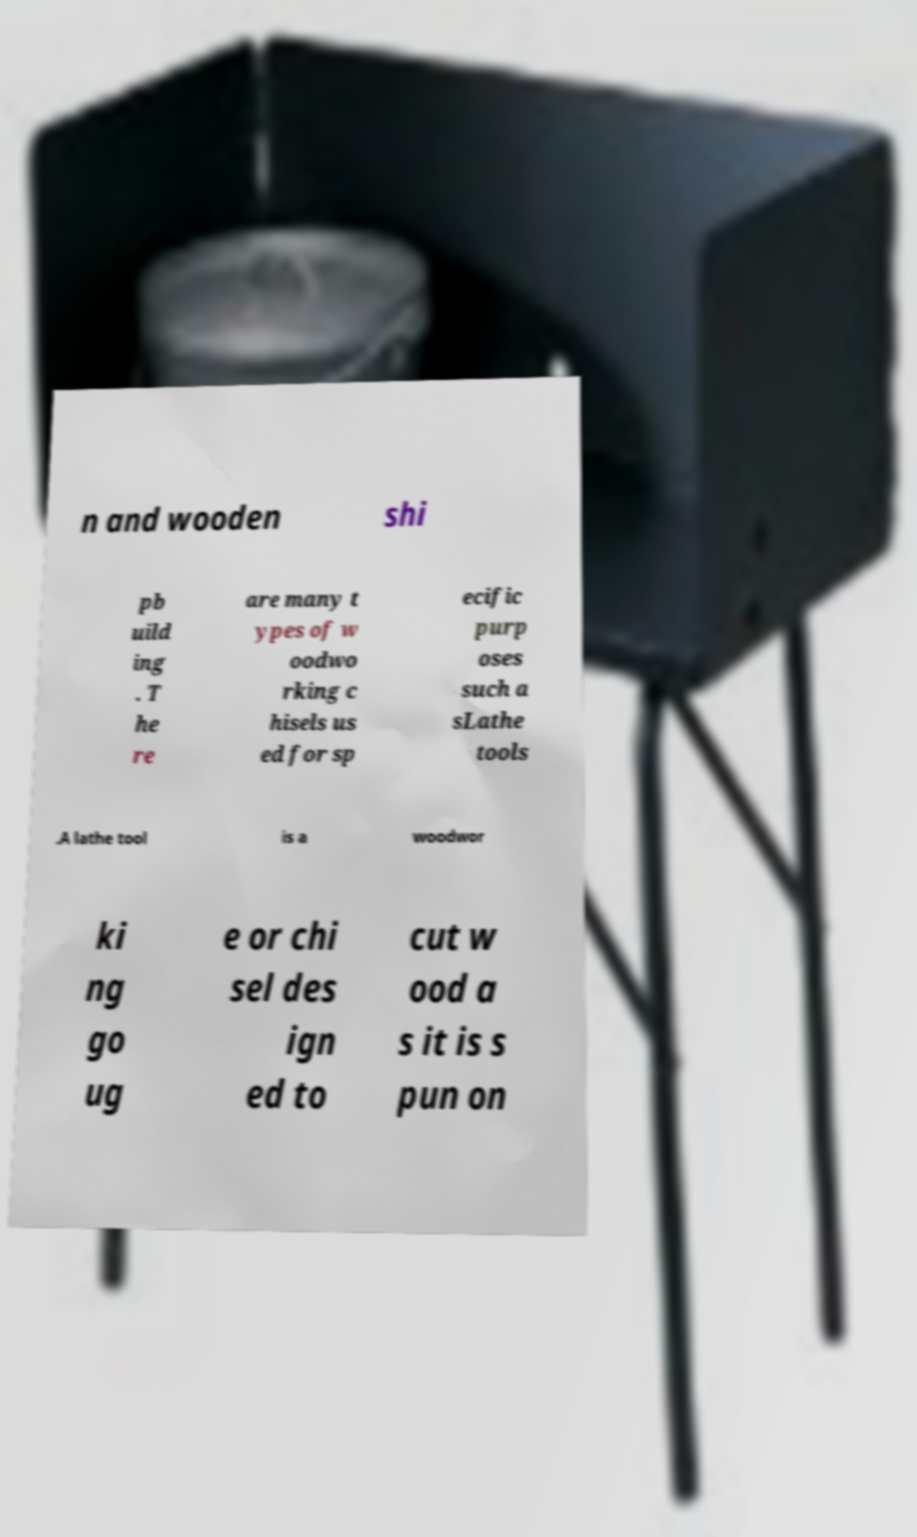There's text embedded in this image that I need extracted. Can you transcribe it verbatim? n and wooden shi pb uild ing . T he re are many t ypes of w oodwo rking c hisels us ed for sp ecific purp oses such a sLathe tools .A lathe tool is a woodwor ki ng go ug e or chi sel des ign ed to cut w ood a s it is s pun on 